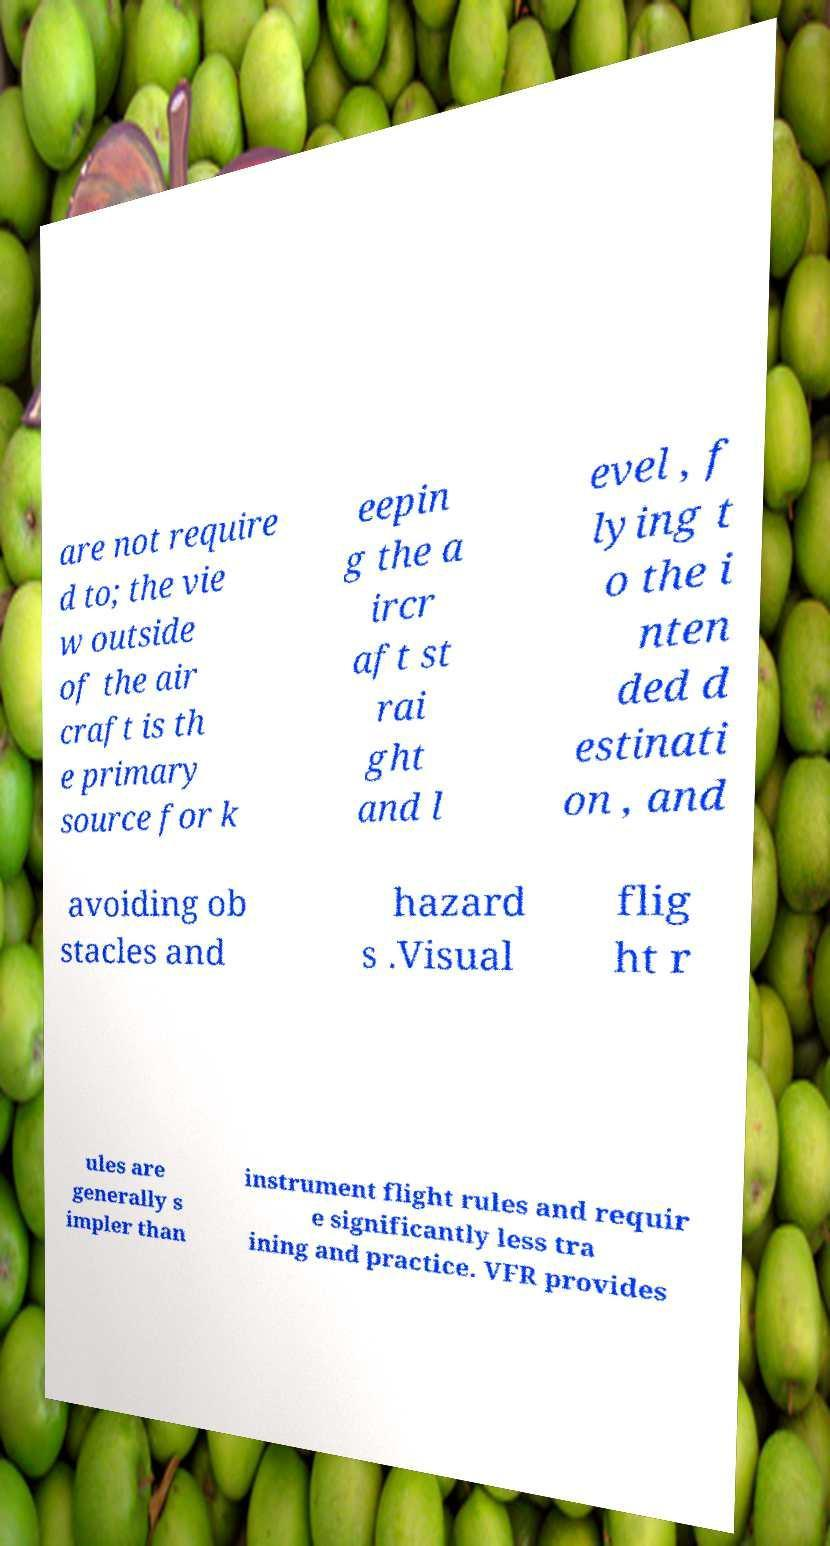What messages or text are displayed in this image? I need them in a readable, typed format. are not require d to; the vie w outside of the air craft is th e primary source for k eepin g the a ircr aft st rai ght and l evel , f lying t o the i nten ded d estinati on , and avoiding ob stacles and hazard s .Visual flig ht r ules are generally s impler than instrument flight rules and requir e significantly less tra ining and practice. VFR provides 